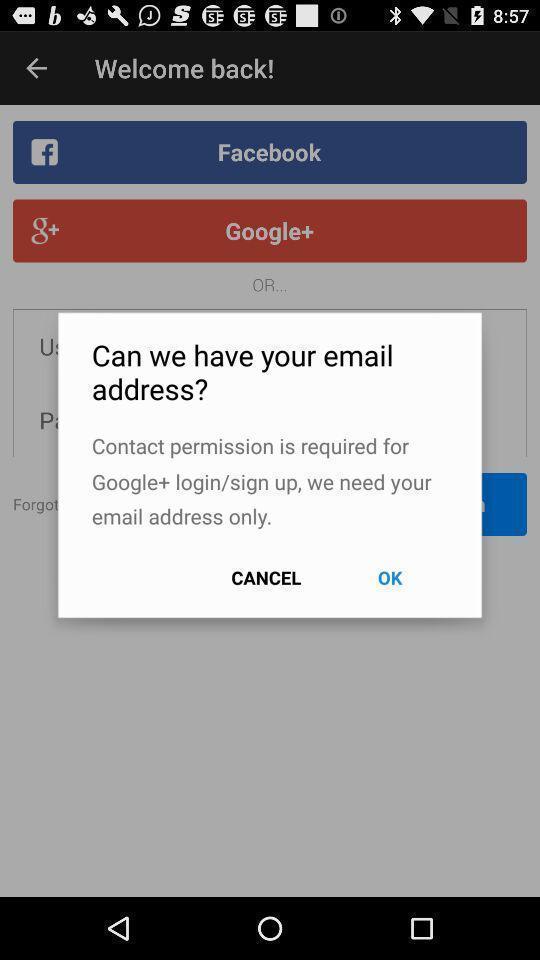Describe this image in words. Popup to login page in a social app. 